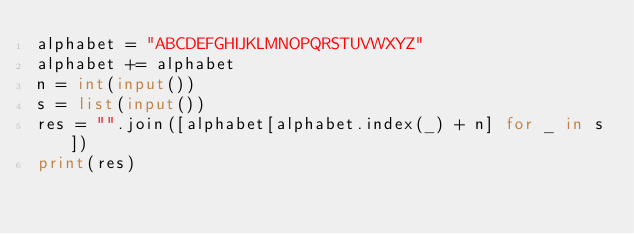Convert code to text. <code><loc_0><loc_0><loc_500><loc_500><_Python_>alphabet = "ABCDEFGHIJKLMNOPQRSTUVWXYZ"
alphabet += alphabet
n = int(input())
s = list(input())
res = "".join([alphabet[alphabet.index(_) + n] for _ in s])
print(res)</code> 